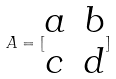<formula> <loc_0><loc_0><loc_500><loc_500>A = [ \begin{matrix} a & b \\ c & d \end{matrix} ]</formula> 